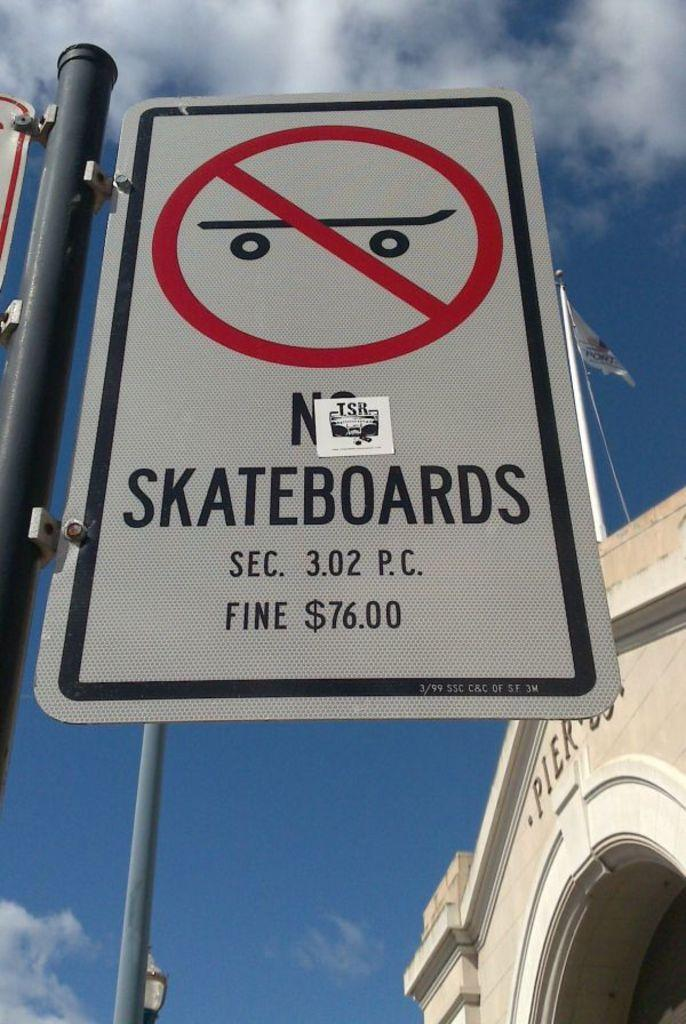<image>
Give a short and clear explanation of the subsequent image. You are not allowed to skateboard on this sidewalk 